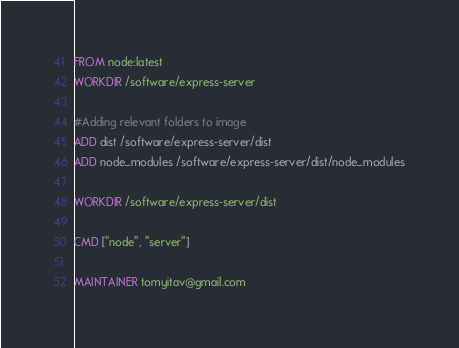<code> <loc_0><loc_0><loc_500><loc_500><_Dockerfile_>FROM node:latest
WORKDIR /software/express-server

#Adding relevant folders to image
ADD dist /software/express-server/dist
ADD node_modules /software/express-server/dist/node_modules

WORKDIR /software/express-server/dist

CMD ["node", "server"]

MAINTAINER tomyitav@gmail.com</code> 